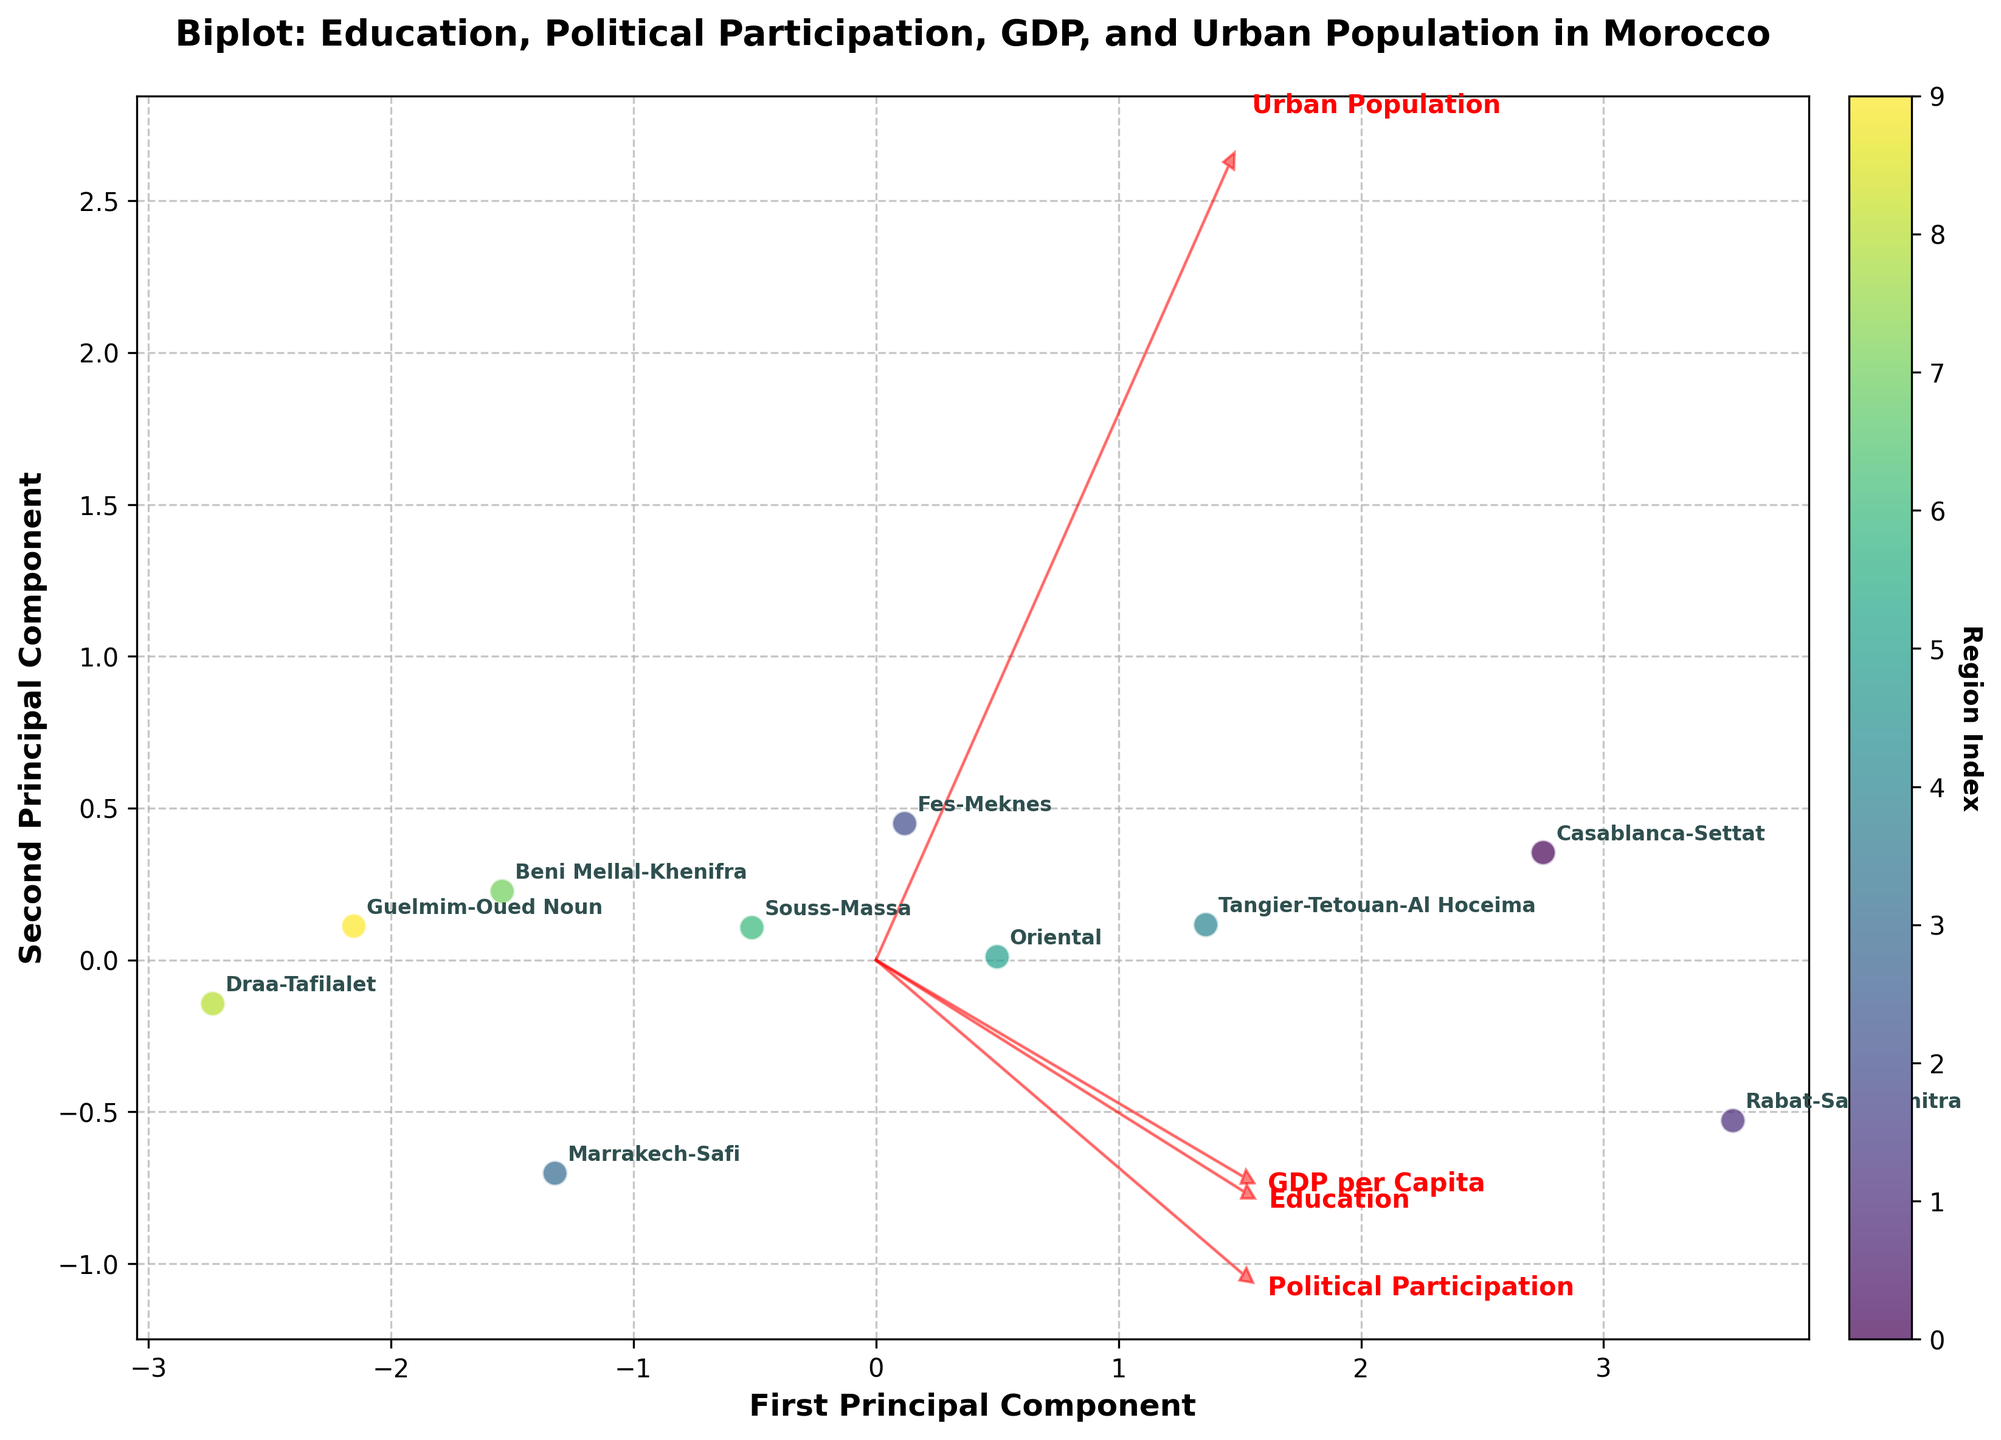What is the title of the plot? The title of the plot is displayed at the top of the figure. It reads "Biplot: Education, Political Participation, GDP, and Urban Population in Morocco."
Answer: Biplot: Education, Political Participation, GDP, and Urban Population in Morocco How many regions are represented in the plot? The regions are labeled on the plot. By counting the labels, you can see there are 10 regions represented.
Answer: 10 Which feature name is closest to the first principal component? Feature names are annotated on the plot, and the one closest to the first principal component (x-axis) appears to be "GDP per Capita."
Answer: GDP per Capita Which region has the highest political participation rate according to the plot? By looking at the distribution of the points and their annotations, "Rabat-Sale-Kenitra" is the region that has the highest political participation rate.
Answer: Rabat-Sale-Kenitra Is there a noticeable correlation between education level and political participation rate? The biplot shows vectors for Education and Political Participation that are both pointing in similar directions, indicating a positive correlation.
Answer: Yes Compare the urban population percentage between Casablanca-Settat and Marrakech-Safi. Which one is higher? By checking the annotated regions on the plot along with the direction of the Urban Population vector, Casablanca-Settat's point is closer to the higher end of the vector than Marrakech-Safi.
Answer: Casablanca-Settat Identify a region with both low GDP per capita and low political participation rate. The vectors and region distribution show that "Draa-Tafilalet" is positioned near the origin, closer to the lower ends of both GDP per Capita and Political Participation vectors.
Answer: Draa-Tafilalet Which principal component explains more variance in the data? By looking at the axis labels, typically the first principal component explains more variance in PCA biplots. Therefore, the first principal component (x-axis) should explain more variance.
Answer: First Principal Component Compare the locations of Fes-Meknes and Tangier-Tetouan-Al Hoceima in the biplot. Which region has higher GDP per capita? Fes-Meknes and Tangier-Tetouan-Al Hoceima are annotated on the plot; the region further in the direction of the GDP per Capita vector is Tangier-Tetouan-Al Hoceima.
Answer: Tangier-Tetouan-Al Hoceima Which feature appears to be least correlated with the second principal component? By observing the vector directions, the feature vector that is closest to being perpendicular to the second principal component's direction (y-axis) is "Urban Population."
Answer: Urban Population 